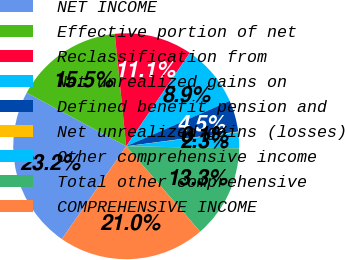Convert chart to OTSL. <chart><loc_0><loc_0><loc_500><loc_500><pie_chart><fcel>NET INCOME<fcel>Effective portion of net<fcel>Reclassification from<fcel>Net unrealized gains on<fcel>Defined benefit pension and<fcel>Net unrealized gains (losses)<fcel>Other comprehensive income<fcel>Total other comprehensive<fcel>COMPREHENSIVE INCOME<nl><fcel>23.21%<fcel>15.54%<fcel>11.13%<fcel>8.92%<fcel>4.5%<fcel>0.08%<fcel>2.29%<fcel>13.34%<fcel>21.0%<nl></chart> 